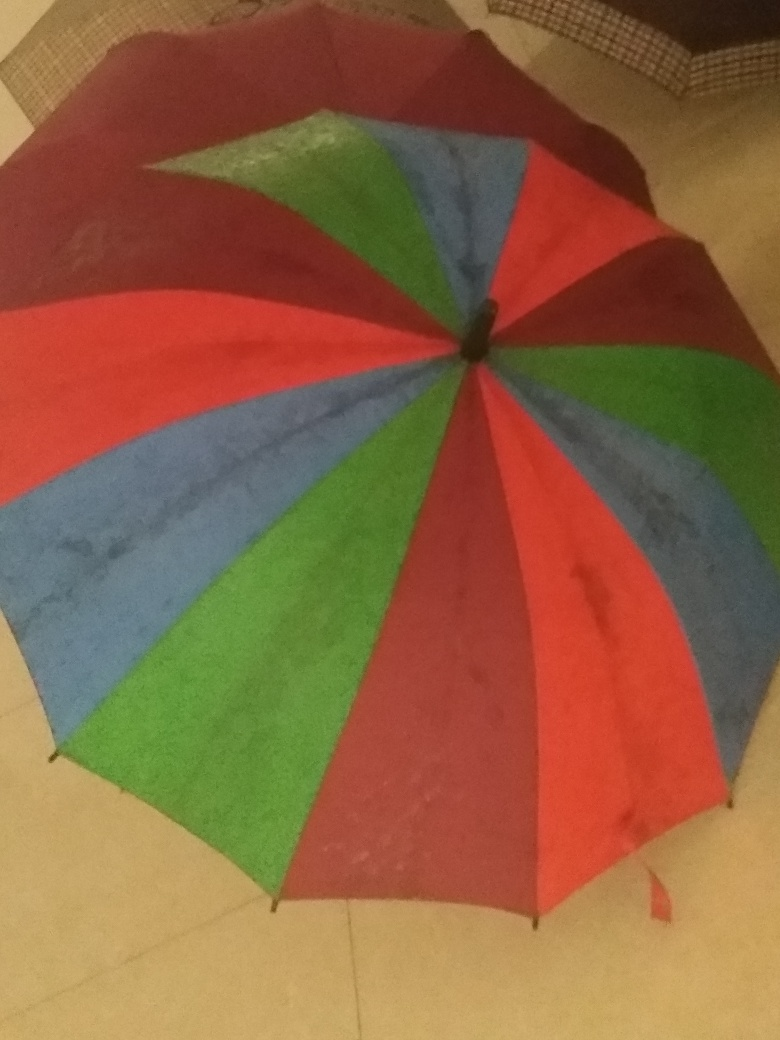Is the content of this image complete? From what I can observe, the image appears incomplete as it only shows a portion of a multicolored umbrella with segments of red, blue, and green, but does not provide a full view of the object or its surroundings. A complete content would ideally provide a full view and more context. 